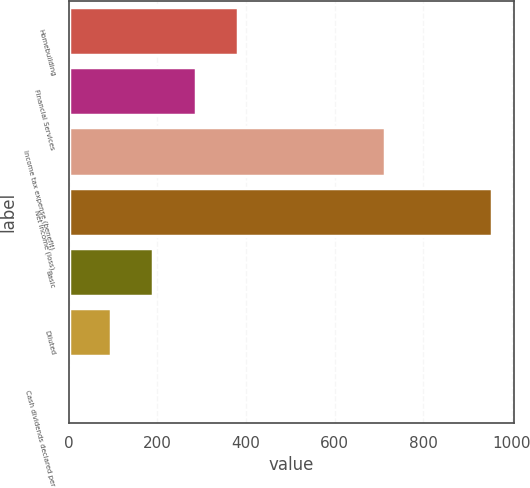Convert chart. <chart><loc_0><loc_0><loc_500><loc_500><bar_chart><fcel>Homebuilding<fcel>Financial Services<fcel>Income tax expense (benefit)<fcel>Net income (loss)<fcel>Basic<fcel>Diluted<fcel>Cash dividends declared per<nl><fcel>382.62<fcel>287<fcel>713.4<fcel>956.3<fcel>191.38<fcel>95.77<fcel>0.15<nl></chart> 